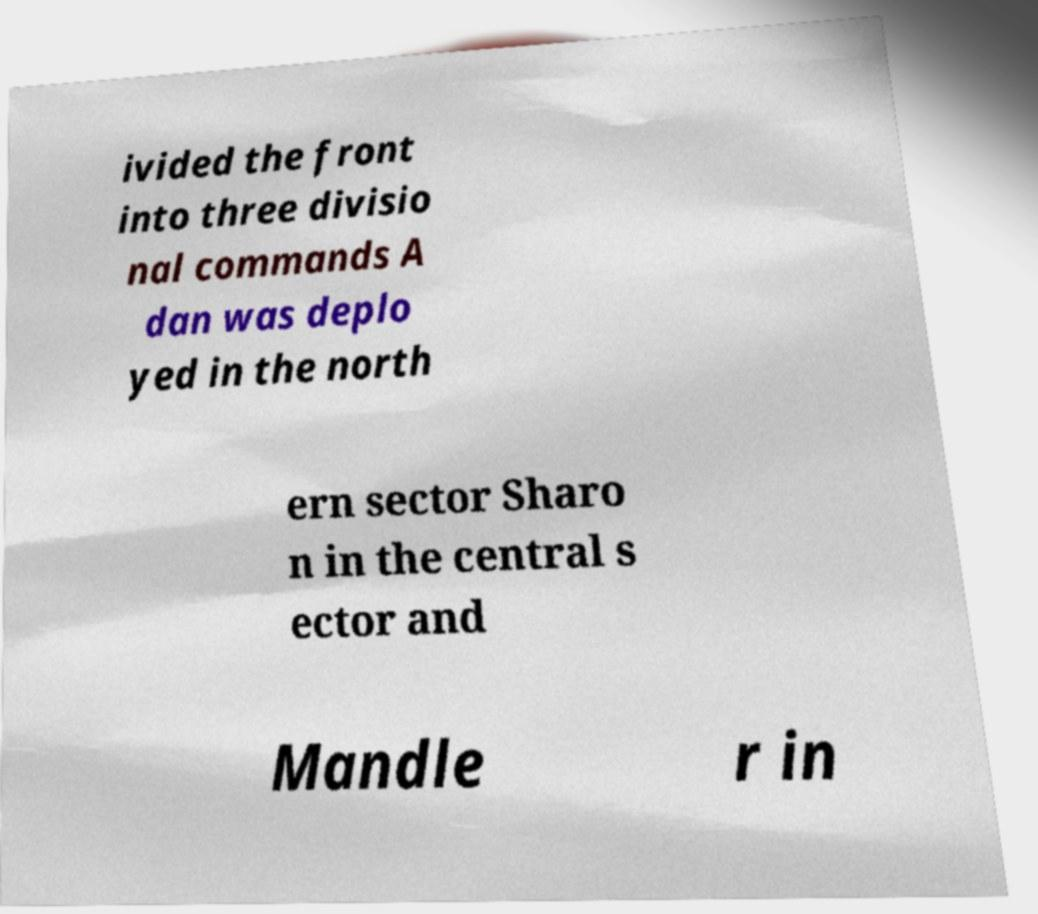Could you assist in decoding the text presented in this image and type it out clearly? ivided the front into three divisio nal commands A dan was deplo yed in the north ern sector Sharo n in the central s ector and Mandle r in 